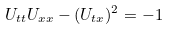<formula> <loc_0><loc_0><loc_500><loc_500>U _ { t t } U _ { x x } - ( U _ { t x } ) ^ { 2 } = - 1</formula> 